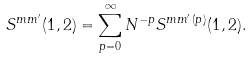Convert formula to latex. <formula><loc_0><loc_0><loc_500><loc_500>S ^ { m m ^ { \prime } } ( 1 , 2 ) = \sum _ { p = 0 } ^ { \infty } N ^ { - p } S ^ { m m ^ { \prime } \, ( p ) } ( 1 , 2 ) .</formula> 